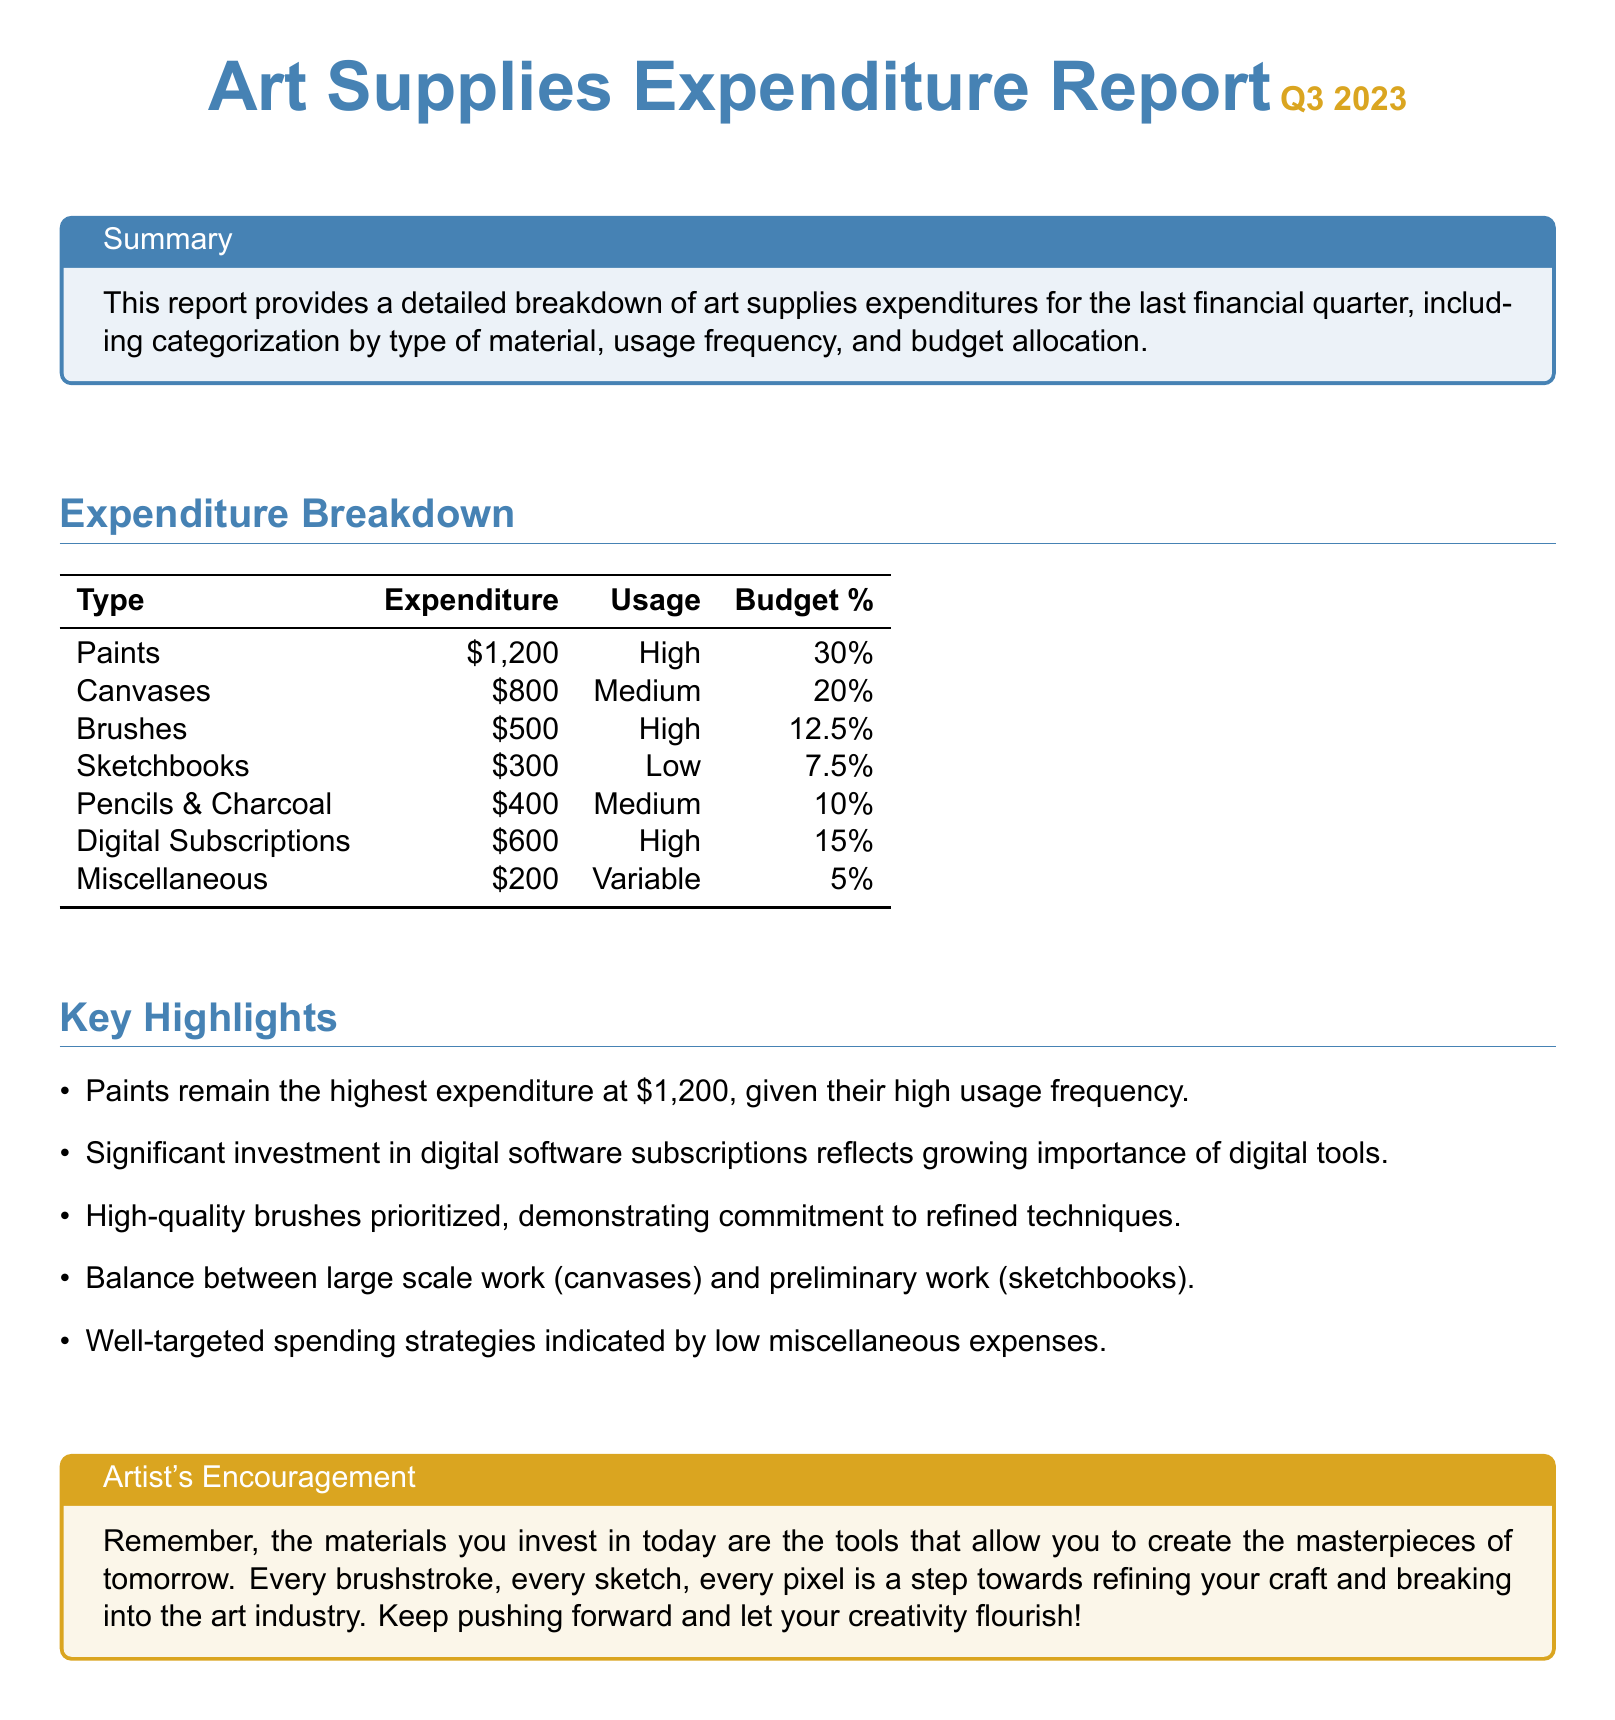What was the highest expenditure on art supplies? The highest expenditure on art supplies is provided in the table, indicating the amount spent on paints.
Answer: $1,200 What percentage of the budget was allocated to sketchbooks? The budget percentage for sketchbooks is listed in the expenditure breakdown table.
Answer: 7.5% How much was spent on brushes? The document specifies the expenditure for brushes in the expenditure breakdown.
Answer: $500 What is the usage frequency of digital subscriptions? The usage frequency for digital subscriptions is identified in the table as high usage.
Answer: High Which type of material had the lowest expenditure? The lowest expenditure type can be determined by analyzing the expenditure breakdown table.
Answer: Miscellaneous What total percentage of the budget is spent on paints and canvases combined? By adding the budget percentages for paints and canvases from the table, we can find the combined percentage.
Answer: 50% Which material shows a commitment to refined techniques based on expenditure? The document highlights the high-quality brushes to signify commitment to refined techniques.
Answer: Brushes What is the overall trend in digital tool investment? The report notes significant investment in digital software subscriptions, highlighting a trend.
Answer: Growing importance What is included in the miscellaneous category? The miscellaneous category is defined as variable usage in the expenditure breakdown.
Answer: Variable 